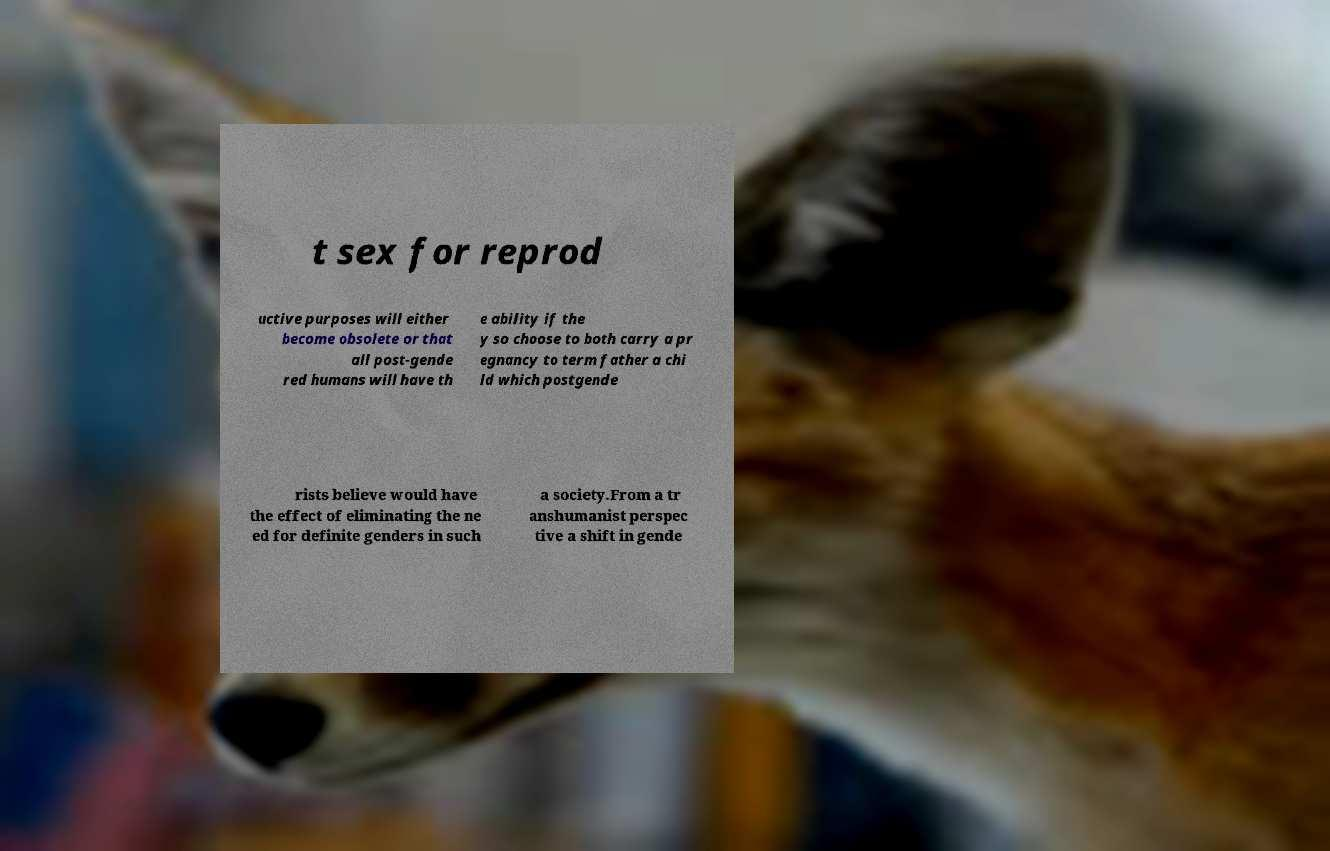Could you assist in decoding the text presented in this image and type it out clearly? t sex for reprod uctive purposes will either become obsolete or that all post-gende red humans will have th e ability if the y so choose to both carry a pr egnancy to term father a chi ld which postgende rists believe would have the effect of eliminating the ne ed for definite genders in such a society.From a tr anshumanist perspec tive a shift in gende 